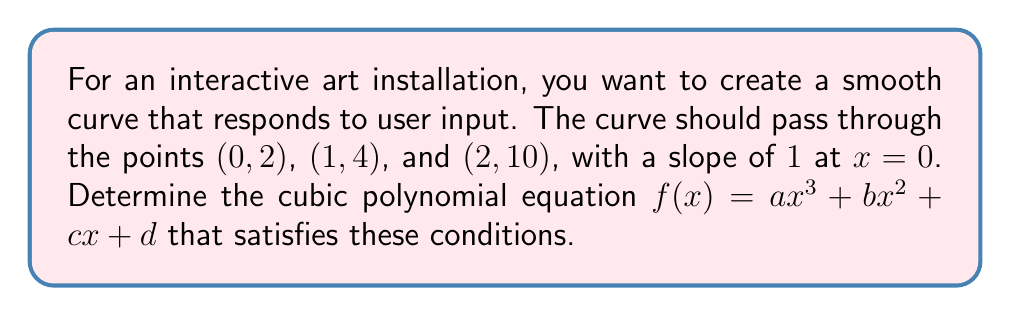Give your solution to this math problem. Let's approach this step-by-step:

1) We're looking for a cubic polynomial of the form $f(x) = ax^3 + bx^2 + cx + d$.

2) We have four conditions to satisfy:
   a) $f(0) = 2$
   b) $f(1) = 4$
   c) $f(2) = 10$
   d) $f'(0) = 1$

3) Let's use these conditions to set up equations:

   a) $f(0) = 2$ implies $d = 2$

   b) $f'(x) = 3ax^2 + 2bx + c$, so $f'(0) = 1$ implies $c = 1$

   c) $f(1) = 4$ gives us: $a + b + 1 + 2 = 4$, or $a + b = 1$

   d) $f(2) = 10$ gives us: $8a + 4b + 2 + 2 = 10$, or $8a + 4b = 6$

4) We now have two equations with two unknowns:
   $a + b = 1$
   $8a + 4b = 6$

5) Multiply the first equation by 4:
   $4a + 4b = 4$
   $8a + 4b = 6$

6) Subtracting these equations:
   $-4a = -2$
   $a = \frac{1}{2}$

7) Substitute this back into $a + b = 1$:
   $\frac{1}{2} + b = 1$
   $b = \frac{1}{2}$

8) We now have all coefficients: $a = \frac{1}{2}$, $b = \frac{1}{2}$, $c = 1$, $d = 2$
Answer: The cubic polynomial equation is:

$$f(x) = \frac{1}{2}x^3 + \frac{1}{2}x^2 + x + 2$$ 